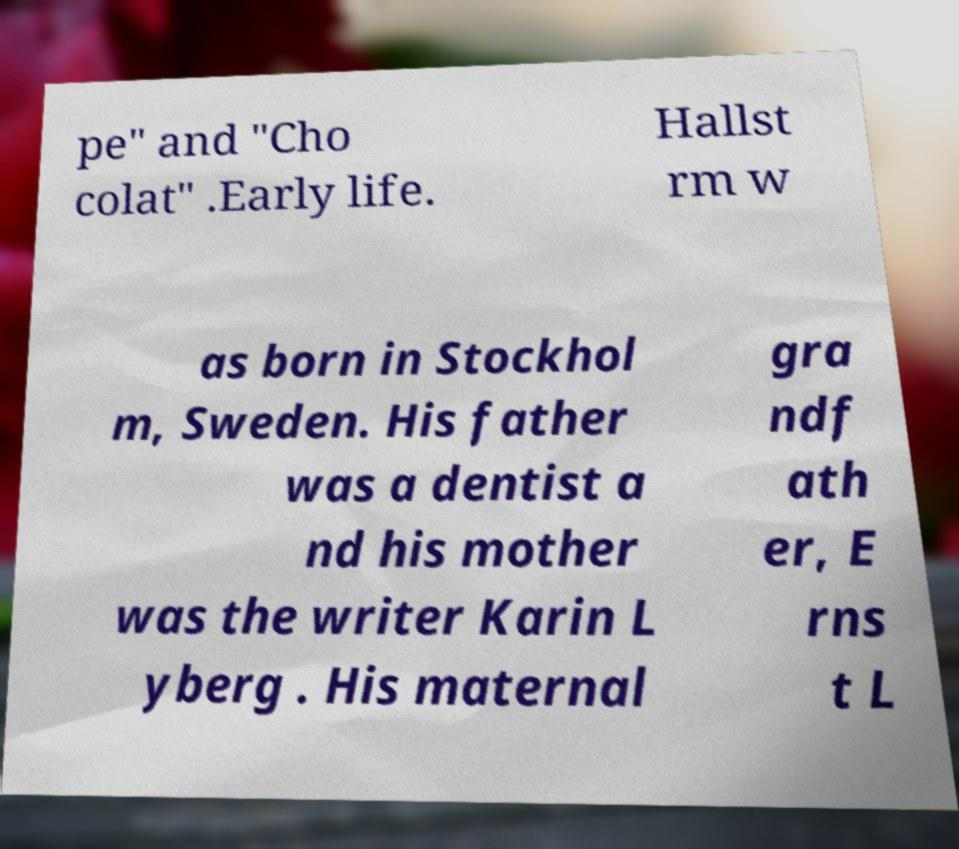For documentation purposes, I need the text within this image transcribed. Could you provide that? pe" and "Cho colat" .Early life. Hallst rm w as born in Stockhol m, Sweden. His father was a dentist a nd his mother was the writer Karin L yberg . His maternal gra ndf ath er, E rns t L 